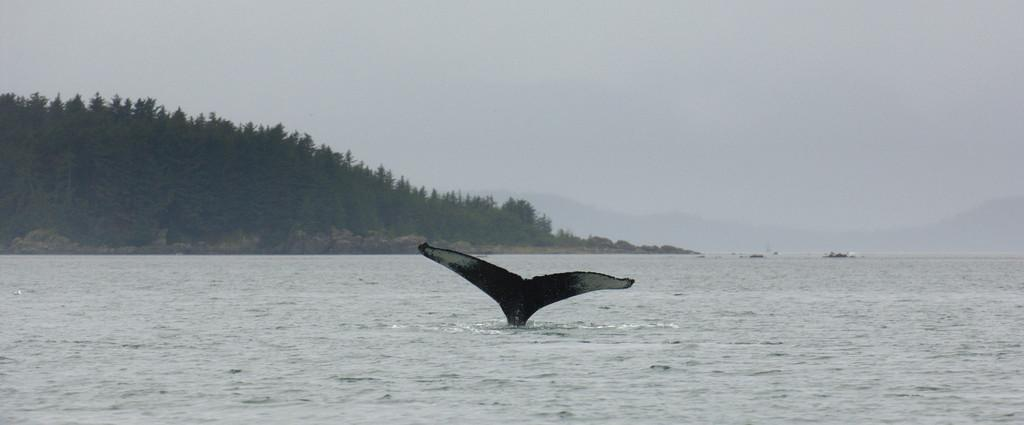What is the main subject in the center of the image? There is a whale in the water in the center of the image. What can be seen in the background of the image? There are trees, hills, and the sky visible in the background of the image. Where is the boy riding the wheel in the image? There is no boy or wheel present in the image; it features a whale in the water and background elements such as trees, hills, and the sky. 